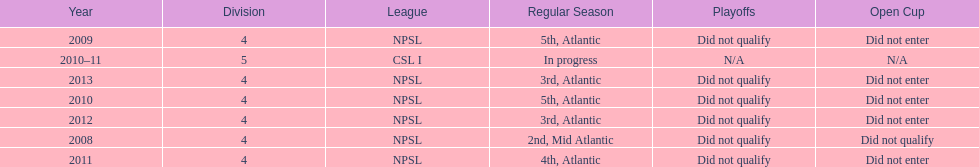How did they place the year after they were 4th in the regular season? 3rd. 